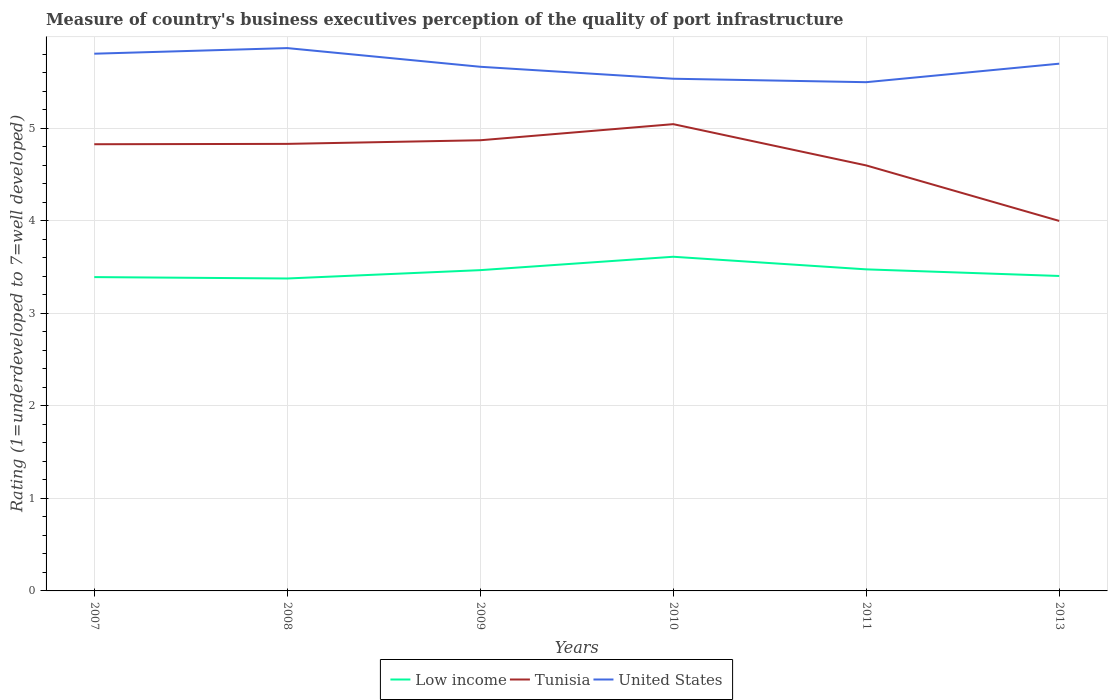Does the line corresponding to Tunisia intersect with the line corresponding to Low income?
Keep it short and to the point. No. Is the number of lines equal to the number of legend labels?
Your answer should be compact. Yes. Across all years, what is the maximum ratings of the quality of port infrastructure in Tunisia?
Offer a terse response. 4. In which year was the ratings of the quality of port infrastructure in United States maximum?
Ensure brevity in your answer.  2011. What is the total ratings of the quality of port infrastructure in United States in the graph?
Provide a succinct answer. 0.27. What is the difference between the highest and the second highest ratings of the quality of port infrastructure in United States?
Keep it short and to the point. 0.37. What is the difference between the highest and the lowest ratings of the quality of port infrastructure in Low income?
Make the answer very short. 3. How many years are there in the graph?
Offer a very short reply. 6. Does the graph contain any zero values?
Keep it short and to the point. No. Where does the legend appear in the graph?
Provide a succinct answer. Bottom center. How many legend labels are there?
Provide a succinct answer. 3. What is the title of the graph?
Ensure brevity in your answer.  Measure of country's business executives perception of the quality of port infrastructure. Does "Euro area" appear as one of the legend labels in the graph?
Offer a terse response. No. What is the label or title of the Y-axis?
Offer a terse response. Rating (1=underdeveloped to 7=well developed). What is the Rating (1=underdeveloped to 7=well developed) in Low income in 2007?
Ensure brevity in your answer.  3.39. What is the Rating (1=underdeveloped to 7=well developed) of Tunisia in 2007?
Your answer should be very brief. 4.83. What is the Rating (1=underdeveloped to 7=well developed) in United States in 2007?
Keep it short and to the point. 5.81. What is the Rating (1=underdeveloped to 7=well developed) in Low income in 2008?
Offer a very short reply. 3.38. What is the Rating (1=underdeveloped to 7=well developed) of Tunisia in 2008?
Offer a very short reply. 4.83. What is the Rating (1=underdeveloped to 7=well developed) of United States in 2008?
Your answer should be very brief. 5.87. What is the Rating (1=underdeveloped to 7=well developed) of Low income in 2009?
Give a very brief answer. 3.47. What is the Rating (1=underdeveloped to 7=well developed) of Tunisia in 2009?
Your answer should be compact. 4.87. What is the Rating (1=underdeveloped to 7=well developed) in United States in 2009?
Your response must be concise. 5.67. What is the Rating (1=underdeveloped to 7=well developed) in Low income in 2010?
Your answer should be compact. 3.61. What is the Rating (1=underdeveloped to 7=well developed) in Tunisia in 2010?
Your response must be concise. 5.05. What is the Rating (1=underdeveloped to 7=well developed) of United States in 2010?
Keep it short and to the point. 5.54. What is the Rating (1=underdeveloped to 7=well developed) of Low income in 2011?
Provide a short and direct response. 3.48. What is the Rating (1=underdeveloped to 7=well developed) in Tunisia in 2011?
Provide a succinct answer. 4.6. What is the Rating (1=underdeveloped to 7=well developed) in Low income in 2013?
Your answer should be compact. 3.4. What is the Rating (1=underdeveloped to 7=well developed) in Tunisia in 2013?
Provide a succinct answer. 4. What is the Rating (1=underdeveloped to 7=well developed) of United States in 2013?
Provide a succinct answer. 5.7. Across all years, what is the maximum Rating (1=underdeveloped to 7=well developed) of Low income?
Your response must be concise. 3.61. Across all years, what is the maximum Rating (1=underdeveloped to 7=well developed) in Tunisia?
Offer a terse response. 5.05. Across all years, what is the maximum Rating (1=underdeveloped to 7=well developed) of United States?
Keep it short and to the point. 5.87. Across all years, what is the minimum Rating (1=underdeveloped to 7=well developed) of Low income?
Ensure brevity in your answer.  3.38. What is the total Rating (1=underdeveloped to 7=well developed) in Low income in the graph?
Provide a succinct answer. 20.73. What is the total Rating (1=underdeveloped to 7=well developed) in Tunisia in the graph?
Keep it short and to the point. 28.18. What is the total Rating (1=underdeveloped to 7=well developed) in United States in the graph?
Keep it short and to the point. 34.08. What is the difference between the Rating (1=underdeveloped to 7=well developed) of Low income in 2007 and that in 2008?
Your answer should be very brief. 0.01. What is the difference between the Rating (1=underdeveloped to 7=well developed) in Tunisia in 2007 and that in 2008?
Give a very brief answer. -0. What is the difference between the Rating (1=underdeveloped to 7=well developed) of United States in 2007 and that in 2008?
Offer a terse response. -0.06. What is the difference between the Rating (1=underdeveloped to 7=well developed) in Low income in 2007 and that in 2009?
Offer a very short reply. -0.08. What is the difference between the Rating (1=underdeveloped to 7=well developed) in Tunisia in 2007 and that in 2009?
Provide a short and direct response. -0.04. What is the difference between the Rating (1=underdeveloped to 7=well developed) in United States in 2007 and that in 2009?
Your response must be concise. 0.14. What is the difference between the Rating (1=underdeveloped to 7=well developed) in Low income in 2007 and that in 2010?
Offer a terse response. -0.22. What is the difference between the Rating (1=underdeveloped to 7=well developed) of Tunisia in 2007 and that in 2010?
Offer a terse response. -0.22. What is the difference between the Rating (1=underdeveloped to 7=well developed) of United States in 2007 and that in 2010?
Ensure brevity in your answer.  0.27. What is the difference between the Rating (1=underdeveloped to 7=well developed) of Low income in 2007 and that in 2011?
Keep it short and to the point. -0.08. What is the difference between the Rating (1=underdeveloped to 7=well developed) in Tunisia in 2007 and that in 2011?
Provide a short and direct response. 0.23. What is the difference between the Rating (1=underdeveloped to 7=well developed) in United States in 2007 and that in 2011?
Your answer should be very brief. 0.31. What is the difference between the Rating (1=underdeveloped to 7=well developed) in Low income in 2007 and that in 2013?
Your response must be concise. -0.01. What is the difference between the Rating (1=underdeveloped to 7=well developed) in Tunisia in 2007 and that in 2013?
Your answer should be very brief. 0.83. What is the difference between the Rating (1=underdeveloped to 7=well developed) in United States in 2007 and that in 2013?
Keep it short and to the point. 0.11. What is the difference between the Rating (1=underdeveloped to 7=well developed) of Low income in 2008 and that in 2009?
Ensure brevity in your answer.  -0.09. What is the difference between the Rating (1=underdeveloped to 7=well developed) in Tunisia in 2008 and that in 2009?
Keep it short and to the point. -0.04. What is the difference between the Rating (1=underdeveloped to 7=well developed) of United States in 2008 and that in 2009?
Make the answer very short. 0.2. What is the difference between the Rating (1=underdeveloped to 7=well developed) in Low income in 2008 and that in 2010?
Offer a very short reply. -0.23. What is the difference between the Rating (1=underdeveloped to 7=well developed) of Tunisia in 2008 and that in 2010?
Your response must be concise. -0.21. What is the difference between the Rating (1=underdeveloped to 7=well developed) of United States in 2008 and that in 2010?
Offer a very short reply. 0.33. What is the difference between the Rating (1=underdeveloped to 7=well developed) in Low income in 2008 and that in 2011?
Provide a succinct answer. -0.1. What is the difference between the Rating (1=underdeveloped to 7=well developed) in Tunisia in 2008 and that in 2011?
Offer a terse response. 0.23. What is the difference between the Rating (1=underdeveloped to 7=well developed) of United States in 2008 and that in 2011?
Provide a succinct answer. 0.37. What is the difference between the Rating (1=underdeveloped to 7=well developed) in Low income in 2008 and that in 2013?
Make the answer very short. -0.03. What is the difference between the Rating (1=underdeveloped to 7=well developed) of Tunisia in 2008 and that in 2013?
Keep it short and to the point. 0.83. What is the difference between the Rating (1=underdeveloped to 7=well developed) of United States in 2008 and that in 2013?
Provide a succinct answer. 0.17. What is the difference between the Rating (1=underdeveloped to 7=well developed) of Low income in 2009 and that in 2010?
Make the answer very short. -0.14. What is the difference between the Rating (1=underdeveloped to 7=well developed) in Tunisia in 2009 and that in 2010?
Offer a very short reply. -0.17. What is the difference between the Rating (1=underdeveloped to 7=well developed) in United States in 2009 and that in 2010?
Offer a terse response. 0.13. What is the difference between the Rating (1=underdeveloped to 7=well developed) in Low income in 2009 and that in 2011?
Give a very brief answer. -0.01. What is the difference between the Rating (1=underdeveloped to 7=well developed) in Tunisia in 2009 and that in 2011?
Your response must be concise. 0.27. What is the difference between the Rating (1=underdeveloped to 7=well developed) of United States in 2009 and that in 2011?
Give a very brief answer. 0.17. What is the difference between the Rating (1=underdeveloped to 7=well developed) of Low income in 2009 and that in 2013?
Provide a succinct answer. 0.06. What is the difference between the Rating (1=underdeveloped to 7=well developed) of Tunisia in 2009 and that in 2013?
Your response must be concise. 0.87. What is the difference between the Rating (1=underdeveloped to 7=well developed) in United States in 2009 and that in 2013?
Provide a succinct answer. -0.03. What is the difference between the Rating (1=underdeveloped to 7=well developed) of Low income in 2010 and that in 2011?
Offer a terse response. 0.14. What is the difference between the Rating (1=underdeveloped to 7=well developed) in Tunisia in 2010 and that in 2011?
Offer a terse response. 0.45. What is the difference between the Rating (1=underdeveloped to 7=well developed) in United States in 2010 and that in 2011?
Make the answer very short. 0.04. What is the difference between the Rating (1=underdeveloped to 7=well developed) of Low income in 2010 and that in 2013?
Make the answer very short. 0.21. What is the difference between the Rating (1=underdeveloped to 7=well developed) of Tunisia in 2010 and that in 2013?
Your answer should be compact. 1.05. What is the difference between the Rating (1=underdeveloped to 7=well developed) of United States in 2010 and that in 2013?
Keep it short and to the point. -0.16. What is the difference between the Rating (1=underdeveloped to 7=well developed) of Low income in 2011 and that in 2013?
Keep it short and to the point. 0.07. What is the difference between the Rating (1=underdeveloped to 7=well developed) of United States in 2011 and that in 2013?
Make the answer very short. -0.2. What is the difference between the Rating (1=underdeveloped to 7=well developed) in Low income in 2007 and the Rating (1=underdeveloped to 7=well developed) in Tunisia in 2008?
Provide a succinct answer. -1.44. What is the difference between the Rating (1=underdeveloped to 7=well developed) of Low income in 2007 and the Rating (1=underdeveloped to 7=well developed) of United States in 2008?
Ensure brevity in your answer.  -2.48. What is the difference between the Rating (1=underdeveloped to 7=well developed) of Tunisia in 2007 and the Rating (1=underdeveloped to 7=well developed) of United States in 2008?
Offer a terse response. -1.04. What is the difference between the Rating (1=underdeveloped to 7=well developed) in Low income in 2007 and the Rating (1=underdeveloped to 7=well developed) in Tunisia in 2009?
Give a very brief answer. -1.48. What is the difference between the Rating (1=underdeveloped to 7=well developed) in Low income in 2007 and the Rating (1=underdeveloped to 7=well developed) in United States in 2009?
Your response must be concise. -2.27. What is the difference between the Rating (1=underdeveloped to 7=well developed) in Tunisia in 2007 and the Rating (1=underdeveloped to 7=well developed) in United States in 2009?
Offer a terse response. -0.84. What is the difference between the Rating (1=underdeveloped to 7=well developed) of Low income in 2007 and the Rating (1=underdeveloped to 7=well developed) of Tunisia in 2010?
Give a very brief answer. -1.65. What is the difference between the Rating (1=underdeveloped to 7=well developed) of Low income in 2007 and the Rating (1=underdeveloped to 7=well developed) of United States in 2010?
Offer a very short reply. -2.14. What is the difference between the Rating (1=underdeveloped to 7=well developed) in Tunisia in 2007 and the Rating (1=underdeveloped to 7=well developed) in United States in 2010?
Keep it short and to the point. -0.71. What is the difference between the Rating (1=underdeveloped to 7=well developed) of Low income in 2007 and the Rating (1=underdeveloped to 7=well developed) of Tunisia in 2011?
Offer a terse response. -1.21. What is the difference between the Rating (1=underdeveloped to 7=well developed) of Low income in 2007 and the Rating (1=underdeveloped to 7=well developed) of United States in 2011?
Make the answer very short. -2.11. What is the difference between the Rating (1=underdeveloped to 7=well developed) of Tunisia in 2007 and the Rating (1=underdeveloped to 7=well developed) of United States in 2011?
Keep it short and to the point. -0.67. What is the difference between the Rating (1=underdeveloped to 7=well developed) in Low income in 2007 and the Rating (1=underdeveloped to 7=well developed) in Tunisia in 2013?
Your answer should be compact. -0.61. What is the difference between the Rating (1=underdeveloped to 7=well developed) in Low income in 2007 and the Rating (1=underdeveloped to 7=well developed) in United States in 2013?
Provide a succinct answer. -2.31. What is the difference between the Rating (1=underdeveloped to 7=well developed) in Tunisia in 2007 and the Rating (1=underdeveloped to 7=well developed) in United States in 2013?
Make the answer very short. -0.87. What is the difference between the Rating (1=underdeveloped to 7=well developed) in Low income in 2008 and the Rating (1=underdeveloped to 7=well developed) in Tunisia in 2009?
Offer a very short reply. -1.49. What is the difference between the Rating (1=underdeveloped to 7=well developed) of Low income in 2008 and the Rating (1=underdeveloped to 7=well developed) of United States in 2009?
Give a very brief answer. -2.29. What is the difference between the Rating (1=underdeveloped to 7=well developed) in Tunisia in 2008 and the Rating (1=underdeveloped to 7=well developed) in United States in 2009?
Provide a succinct answer. -0.83. What is the difference between the Rating (1=underdeveloped to 7=well developed) in Low income in 2008 and the Rating (1=underdeveloped to 7=well developed) in Tunisia in 2010?
Give a very brief answer. -1.67. What is the difference between the Rating (1=underdeveloped to 7=well developed) in Low income in 2008 and the Rating (1=underdeveloped to 7=well developed) in United States in 2010?
Ensure brevity in your answer.  -2.16. What is the difference between the Rating (1=underdeveloped to 7=well developed) in Tunisia in 2008 and the Rating (1=underdeveloped to 7=well developed) in United States in 2010?
Keep it short and to the point. -0.7. What is the difference between the Rating (1=underdeveloped to 7=well developed) of Low income in 2008 and the Rating (1=underdeveloped to 7=well developed) of Tunisia in 2011?
Your answer should be compact. -1.22. What is the difference between the Rating (1=underdeveloped to 7=well developed) in Low income in 2008 and the Rating (1=underdeveloped to 7=well developed) in United States in 2011?
Your response must be concise. -2.12. What is the difference between the Rating (1=underdeveloped to 7=well developed) in Tunisia in 2008 and the Rating (1=underdeveloped to 7=well developed) in United States in 2011?
Give a very brief answer. -0.67. What is the difference between the Rating (1=underdeveloped to 7=well developed) in Low income in 2008 and the Rating (1=underdeveloped to 7=well developed) in Tunisia in 2013?
Ensure brevity in your answer.  -0.62. What is the difference between the Rating (1=underdeveloped to 7=well developed) in Low income in 2008 and the Rating (1=underdeveloped to 7=well developed) in United States in 2013?
Offer a very short reply. -2.32. What is the difference between the Rating (1=underdeveloped to 7=well developed) in Tunisia in 2008 and the Rating (1=underdeveloped to 7=well developed) in United States in 2013?
Offer a very short reply. -0.87. What is the difference between the Rating (1=underdeveloped to 7=well developed) in Low income in 2009 and the Rating (1=underdeveloped to 7=well developed) in Tunisia in 2010?
Keep it short and to the point. -1.58. What is the difference between the Rating (1=underdeveloped to 7=well developed) in Low income in 2009 and the Rating (1=underdeveloped to 7=well developed) in United States in 2010?
Provide a succinct answer. -2.07. What is the difference between the Rating (1=underdeveloped to 7=well developed) in Tunisia in 2009 and the Rating (1=underdeveloped to 7=well developed) in United States in 2010?
Provide a succinct answer. -0.67. What is the difference between the Rating (1=underdeveloped to 7=well developed) in Low income in 2009 and the Rating (1=underdeveloped to 7=well developed) in Tunisia in 2011?
Your answer should be compact. -1.13. What is the difference between the Rating (1=underdeveloped to 7=well developed) in Low income in 2009 and the Rating (1=underdeveloped to 7=well developed) in United States in 2011?
Give a very brief answer. -2.03. What is the difference between the Rating (1=underdeveloped to 7=well developed) of Tunisia in 2009 and the Rating (1=underdeveloped to 7=well developed) of United States in 2011?
Make the answer very short. -0.63. What is the difference between the Rating (1=underdeveloped to 7=well developed) in Low income in 2009 and the Rating (1=underdeveloped to 7=well developed) in Tunisia in 2013?
Provide a short and direct response. -0.53. What is the difference between the Rating (1=underdeveloped to 7=well developed) of Low income in 2009 and the Rating (1=underdeveloped to 7=well developed) of United States in 2013?
Your answer should be compact. -2.23. What is the difference between the Rating (1=underdeveloped to 7=well developed) of Tunisia in 2009 and the Rating (1=underdeveloped to 7=well developed) of United States in 2013?
Provide a succinct answer. -0.83. What is the difference between the Rating (1=underdeveloped to 7=well developed) of Low income in 2010 and the Rating (1=underdeveloped to 7=well developed) of Tunisia in 2011?
Offer a very short reply. -0.99. What is the difference between the Rating (1=underdeveloped to 7=well developed) of Low income in 2010 and the Rating (1=underdeveloped to 7=well developed) of United States in 2011?
Offer a terse response. -1.89. What is the difference between the Rating (1=underdeveloped to 7=well developed) of Tunisia in 2010 and the Rating (1=underdeveloped to 7=well developed) of United States in 2011?
Make the answer very short. -0.45. What is the difference between the Rating (1=underdeveloped to 7=well developed) of Low income in 2010 and the Rating (1=underdeveloped to 7=well developed) of Tunisia in 2013?
Offer a terse response. -0.39. What is the difference between the Rating (1=underdeveloped to 7=well developed) of Low income in 2010 and the Rating (1=underdeveloped to 7=well developed) of United States in 2013?
Ensure brevity in your answer.  -2.09. What is the difference between the Rating (1=underdeveloped to 7=well developed) in Tunisia in 2010 and the Rating (1=underdeveloped to 7=well developed) in United States in 2013?
Provide a succinct answer. -0.65. What is the difference between the Rating (1=underdeveloped to 7=well developed) of Low income in 2011 and the Rating (1=underdeveloped to 7=well developed) of Tunisia in 2013?
Offer a terse response. -0.52. What is the difference between the Rating (1=underdeveloped to 7=well developed) in Low income in 2011 and the Rating (1=underdeveloped to 7=well developed) in United States in 2013?
Your answer should be compact. -2.22. What is the average Rating (1=underdeveloped to 7=well developed) of Low income per year?
Offer a very short reply. 3.46. What is the average Rating (1=underdeveloped to 7=well developed) of Tunisia per year?
Ensure brevity in your answer.  4.7. What is the average Rating (1=underdeveloped to 7=well developed) of United States per year?
Offer a terse response. 5.68. In the year 2007, what is the difference between the Rating (1=underdeveloped to 7=well developed) of Low income and Rating (1=underdeveloped to 7=well developed) of Tunisia?
Your answer should be very brief. -1.44. In the year 2007, what is the difference between the Rating (1=underdeveloped to 7=well developed) in Low income and Rating (1=underdeveloped to 7=well developed) in United States?
Provide a succinct answer. -2.42. In the year 2007, what is the difference between the Rating (1=underdeveloped to 7=well developed) of Tunisia and Rating (1=underdeveloped to 7=well developed) of United States?
Provide a succinct answer. -0.98. In the year 2008, what is the difference between the Rating (1=underdeveloped to 7=well developed) of Low income and Rating (1=underdeveloped to 7=well developed) of Tunisia?
Offer a terse response. -1.46. In the year 2008, what is the difference between the Rating (1=underdeveloped to 7=well developed) in Low income and Rating (1=underdeveloped to 7=well developed) in United States?
Keep it short and to the point. -2.49. In the year 2008, what is the difference between the Rating (1=underdeveloped to 7=well developed) of Tunisia and Rating (1=underdeveloped to 7=well developed) of United States?
Your answer should be compact. -1.04. In the year 2009, what is the difference between the Rating (1=underdeveloped to 7=well developed) of Low income and Rating (1=underdeveloped to 7=well developed) of Tunisia?
Your response must be concise. -1.4. In the year 2009, what is the difference between the Rating (1=underdeveloped to 7=well developed) in Low income and Rating (1=underdeveloped to 7=well developed) in United States?
Your answer should be compact. -2.2. In the year 2009, what is the difference between the Rating (1=underdeveloped to 7=well developed) of Tunisia and Rating (1=underdeveloped to 7=well developed) of United States?
Give a very brief answer. -0.79. In the year 2010, what is the difference between the Rating (1=underdeveloped to 7=well developed) in Low income and Rating (1=underdeveloped to 7=well developed) in Tunisia?
Provide a succinct answer. -1.43. In the year 2010, what is the difference between the Rating (1=underdeveloped to 7=well developed) in Low income and Rating (1=underdeveloped to 7=well developed) in United States?
Give a very brief answer. -1.92. In the year 2010, what is the difference between the Rating (1=underdeveloped to 7=well developed) in Tunisia and Rating (1=underdeveloped to 7=well developed) in United States?
Your answer should be very brief. -0.49. In the year 2011, what is the difference between the Rating (1=underdeveloped to 7=well developed) in Low income and Rating (1=underdeveloped to 7=well developed) in Tunisia?
Your response must be concise. -1.12. In the year 2011, what is the difference between the Rating (1=underdeveloped to 7=well developed) of Low income and Rating (1=underdeveloped to 7=well developed) of United States?
Your answer should be very brief. -2.02. In the year 2011, what is the difference between the Rating (1=underdeveloped to 7=well developed) in Tunisia and Rating (1=underdeveloped to 7=well developed) in United States?
Your answer should be very brief. -0.9. In the year 2013, what is the difference between the Rating (1=underdeveloped to 7=well developed) in Low income and Rating (1=underdeveloped to 7=well developed) in Tunisia?
Offer a very short reply. -0.59. In the year 2013, what is the difference between the Rating (1=underdeveloped to 7=well developed) of Low income and Rating (1=underdeveloped to 7=well developed) of United States?
Your answer should be compact. -2.29. In the year 2013, what is the difference between the Rating (1=underdeveloped to 7=well developed) in Tunisia and Rating (1=underdeveloped to 7=well developed) in United States?
Ensure brevity in your answer.  -1.7. What is the ratio of the Rating (1=underdeveloped to 7=well developed) of Low income in 2007 to that in 2008?
Your response must be concise. 1. What is the ratio of the Rating (1=underdeveloped to 7=well developed) of Tunisia in 2007 to that in 2008?
Your response must be concise. 1. What is the ratio of the Rating (1=underdeveloped to 7=well developed) in Low income in 2007 to that in 2009?
Give a very brief answer. 0.98. What is the ratio of the Rating (1=underdeveloped to 7=well developed) in United States in 2007 to that in 2009?
Keep it short and to the point. 1.02. What is the ratio of the Rating (1=underdeveloped to 7=well developed) in Low income in 2007 to that in 2010?
Your answer should be compact. 0.94. What is the ratio of the Rating (1=underdeveloped to 7=well developed) in United States in 2007 to that in 2010?
Ensure brevity in your answer.  1.05. What is the ratio of the Rating (1=underdeveloped to 7=well developed) of Low income in 2007 to that in 2011?
Provide a succinct answer. 0.98. What is the ratio of the Rating (1=underdeveloped to 7=well developed) in Tunisia in 2007 to that in 2011?
Provide a short and direct response. 1.05. What is the ratio of the Rating (1=underdeveloped to 7=well developed) in United States in 2007 to that in 2011?
Provide a succinct answer. 1.06. What is the ratio of the Rating (1=underdeveloped to 7=well developed) in Tunisia in 2007 to that in 2013?
Provide a short and direct response. 1.21. What is the ratio of the Rating (1=underdeveloped to 7=well developed) of United States in 2007 to that in 2013?
Give a very brief answer. 1.02. What is the ratio of the Rating (1=underdeveloped to 7=well developed) in United States in 2008 to that in 2009?
Ensure brevity in your answer.  1.04. What is the ratio of the Rating (1=underdeveloped to 7=well developed) of Low income in 2008 to that in 2010?
Your answer should be compact. 0.94. What is the ratio of the Rating (1=underdeveloped to 7=well developed) in Tunisia in 2008 to that in 2010?
Ensure brevity in your answer.  0.96. What is the ratio of the Rating (1=underdeveloped to 7=well developed) in United States in 2008 to that in 2010?
Give a very brief answer. 1.06. What is the ratio of the Rating (1=underdeveloped to 7=well developed) of Low income in 2008 to that in 2011?
Your answer should be very brief. 0.97. What is the ratio of the Rating (1=underdeveloped to 7=well developed) of Tunisia in 2008 to that in 2011?
Provide a short and direct response. 1.05. What is the ratio of the Rating (1=underdeveloped to 7=well developed) of United States in 2008 to that in 2011?
Your response must be concise. 1.07. What is the ratio of the Rating (1=underdeveloped to 7=well developed) in Tunisia in 2008 to that in 2013?
Offer a terse response. 1.21. What is the ratio of the Rating (1=underdeveloped to 7=well developed) of United States in 2008 to that in 2013?
Keep it short and to the point. 1.03. What is the ratio of the Rating (1=underdeveloped to 7=well developed) in Low income in 2009 to that in 2010?
Provide a succinct answer. 0.96. What is the ratio of the Rating (1=underdeveloped to 7=well developed) in Tunisia in 2009 to that in 2010?
Your answer should be very brief. 0.97. What is the ratio of the Rating (1=underdeveloped to 7=well developed) in United States in 2009 to that in 2010?
Keep it short and to the point. 1.02. What is the ratio of the Rating (1=underdeveloped to 7=well developed) in Tunisia in 2009 to that in 2011?
Offer a very short reply. 1.06. What is the ratio of the Rating (1=underdeveloped to 7=well developed) in United States in 2009 to that in 2011?
Ensure brevity in your answer.  1.03. What is the ratio of the Rating (1=underdeveloped to 7=well developed) of Low income in 2009 to that in 2013?
Give a very brief answer. 1.02. What is the ratio of the Rating (1=underdeveloped to 7=well developed) of Tunisia in 2009 to that in 2013?
Provide a short and direct response. 1.22. What is the ratio of the Rating (1=underdeveloped to 7=well developed) of Low income in 2010 to that in 2011?
Offer a very short reply. 1.04. What is the ratio of the Rating (1=underdeveloped to 7=well developed) in Tunisia in 2010 to that in 2011?
Ensure brevity in your answer.  1.1. What is the ratio of the Rating (1=underdeveloped to 7=well developed) of United States in 2010 to that in 2011?
Your answer should be compact. 1.01. What is the ratio of the Rating (1=underdeveloped to 7=well developed) of Low income in 2010 to that in 2013?
Your answer should be very brief. 1.06. What is the ratio of the Rating (1=underdeveloped to 7=well developed) of Tunisia in 2010 to that in 2013?
Provide a short and direct response. 1.26. What is the ratio of the Rating (1=underdeveloped to 7=well developed) in United States in 2010 to that in 2013?
Ensure brevity in your answer.  0.97. What is the ratio of the Rating (1=underdeveloped to 7=well developed) in Tunisia in 2011 to that in 2013?
Provide a short and direct response. 1.15. What is the ratio of the Rating (1=underdeveloped to 7=well developed) in United States in 2011 to that in 2013?
Provide a succinct answer. 0.96. What is the difference between the highest and the second highest Rating (1=underdeveloped to 7=well developed) in Low income?
Your answer should be compact. 0.14. What is the difference between the highest and the second highest Rating (1=underdeveloped to 7=well developed) of Tunisia?
Your response must be concise. 0.17. What is the difference between the highest and the second highest Rating (1=underdeveloped to 7=well developed) in United States?
Give a very brief answer. 0.06. What is the difference between the highest and the lowest Rating (1=underdeveloped to 7=well developed) in Low income?
Offer a terse response. 0.23. What is the difference between the highest and the lowest Rating (1=underdeveloped to 7=well developed) of Tunisia?
Offer a terse response. 1.05. What is the difference between the highest and the lowest Rating (1=underdeveloped to 7=well developed) of United States?
Provide a succinct answer. 0.37. 